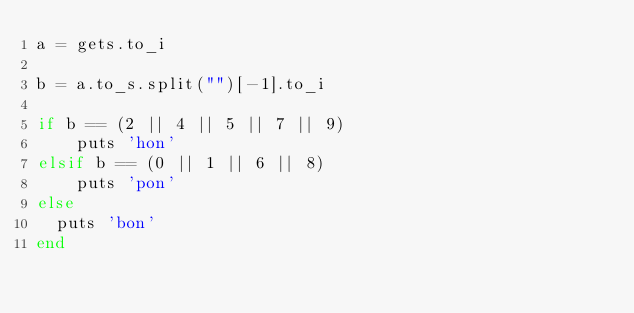Convert code to text. <code><loc_0><loc_0><loc_500><loc_500><_Ruby_>a = gets.to_i

b = a.to_s.split("")[-1].to_i

if b == (2 || 4 || 5 || 7 || 9)
	puts 'hon'
elsif b == (0 || 1 || 6 || 8)
 	puts 'pon'
else
  puts 'bon'
end
 </code> 